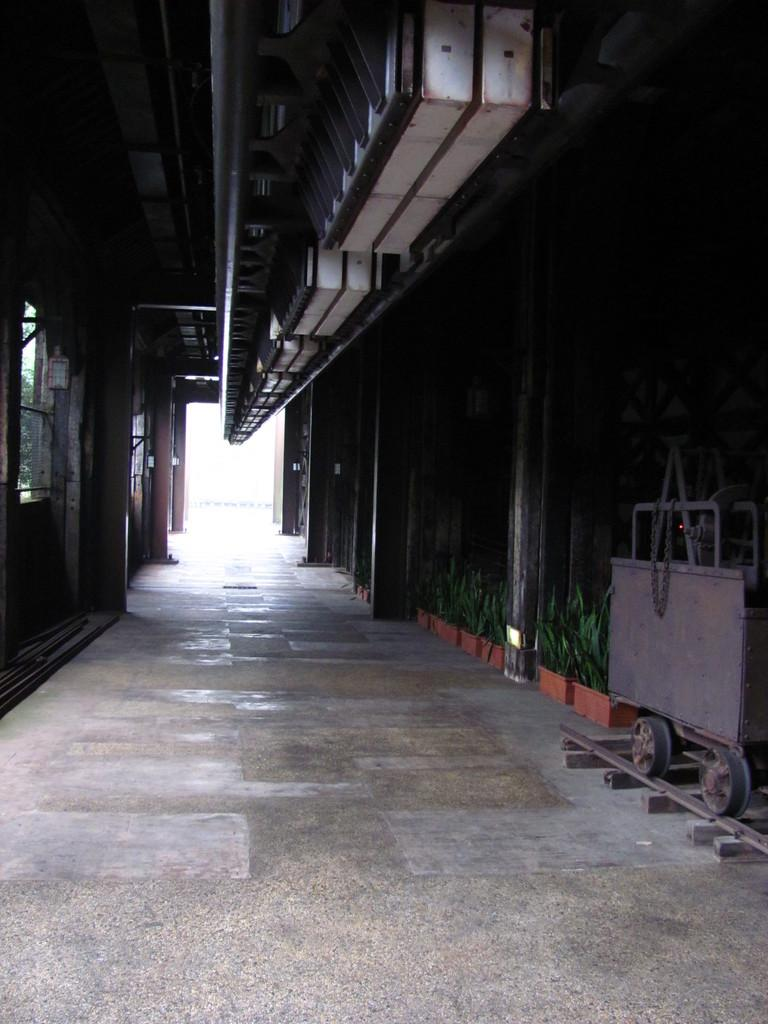What type of location is depicted in the image? The image shows an inside view of a building. What can be seen on the right side of the image? There are plants and a track on the right side of the image. What is located on the track in the image? There is a trolley on the track in the image. What feature is visible on the left side of the image? There appears to be a door on the left side of the image. What type of mine is visible in the image? There is no mine present in the image; it shows an inside view of a building with plants, a track, a trolley, and a door. 